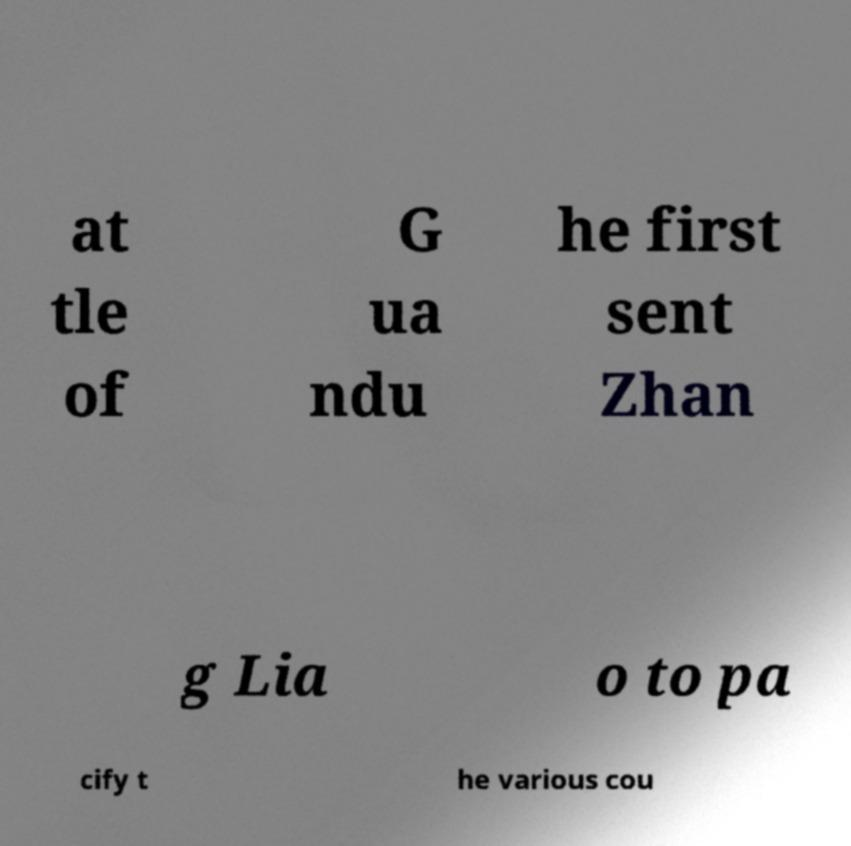Could you extract and type out the text from this image? at tle of G ua ndu he first sent Zhan g Lia o to pa cify t he various cou 